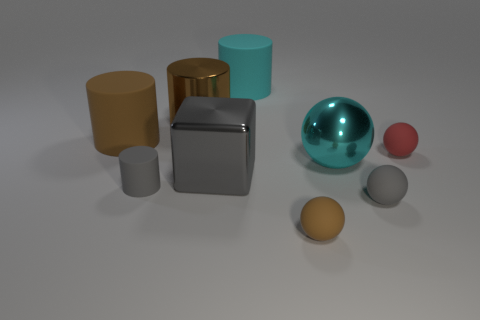How many gray objects have the same shape as the large brown shiny object?
Offer a terse response. 1. How many things are metallic objects to the left of the cube or balls right of the tiny brown rubber object?
Your answer should be compact. 4. How many green objects are balls or tiny rubber things?
Make the answer very short. 0. What is the ball that is both on the right side of the cyan metal thing and behind the big metallic block made of?
Your answer should be very brief. Rubber. Is the material of the gray cylinder the same as the brown ball?
Make the answer very short. Yes. How many brown matte cylinders are the same size as the cyan matte object?
Your response must be concise. 1. Is the number of cylinders right of the brown ball the same as the number of large balls?
Make the answer very short. No. What number of matte cylinders are both on the right side of the brown rubber cylinder and behind the metallic ball?
Provide a short and direct response. 1. Does the small gray object that is in front of the gray matte cylinder have the same shape as the large cyan metal thing?
Give a very brief answer. Yes. There is a block that is the same size as the cyan rubber thing; what material is it?
Make the answer very short. Metal. 